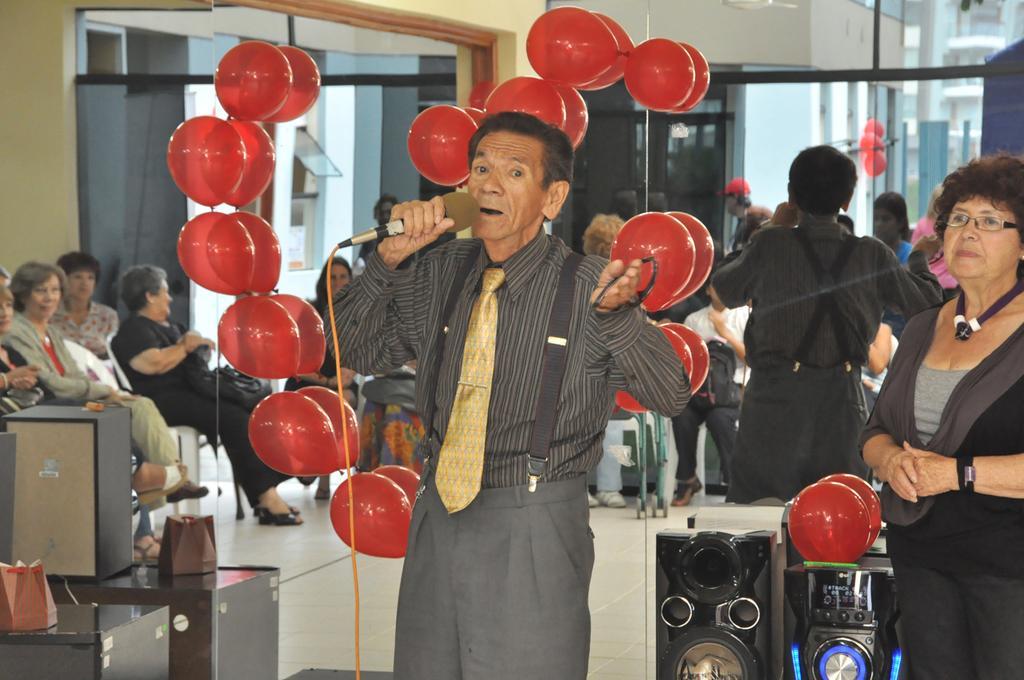Could you give a brief overview of what you see in this image? In this picture, we see a man is standing and he is holding a microphone in one of his hands and in the other hand, he is holding the goggles. I think he is talking on the microphone. Beside him, we see the speaker boxes and the red color balloons. On the right side, we see a woman is standing and she is wearing the spectacles. On the left side, we see the tables on which the objects are placed. Behind him, we see the red balloons and the glass door from which we can see the people who are sitting on the chairs. In the background, we see the buildings, poles and the balloons. 